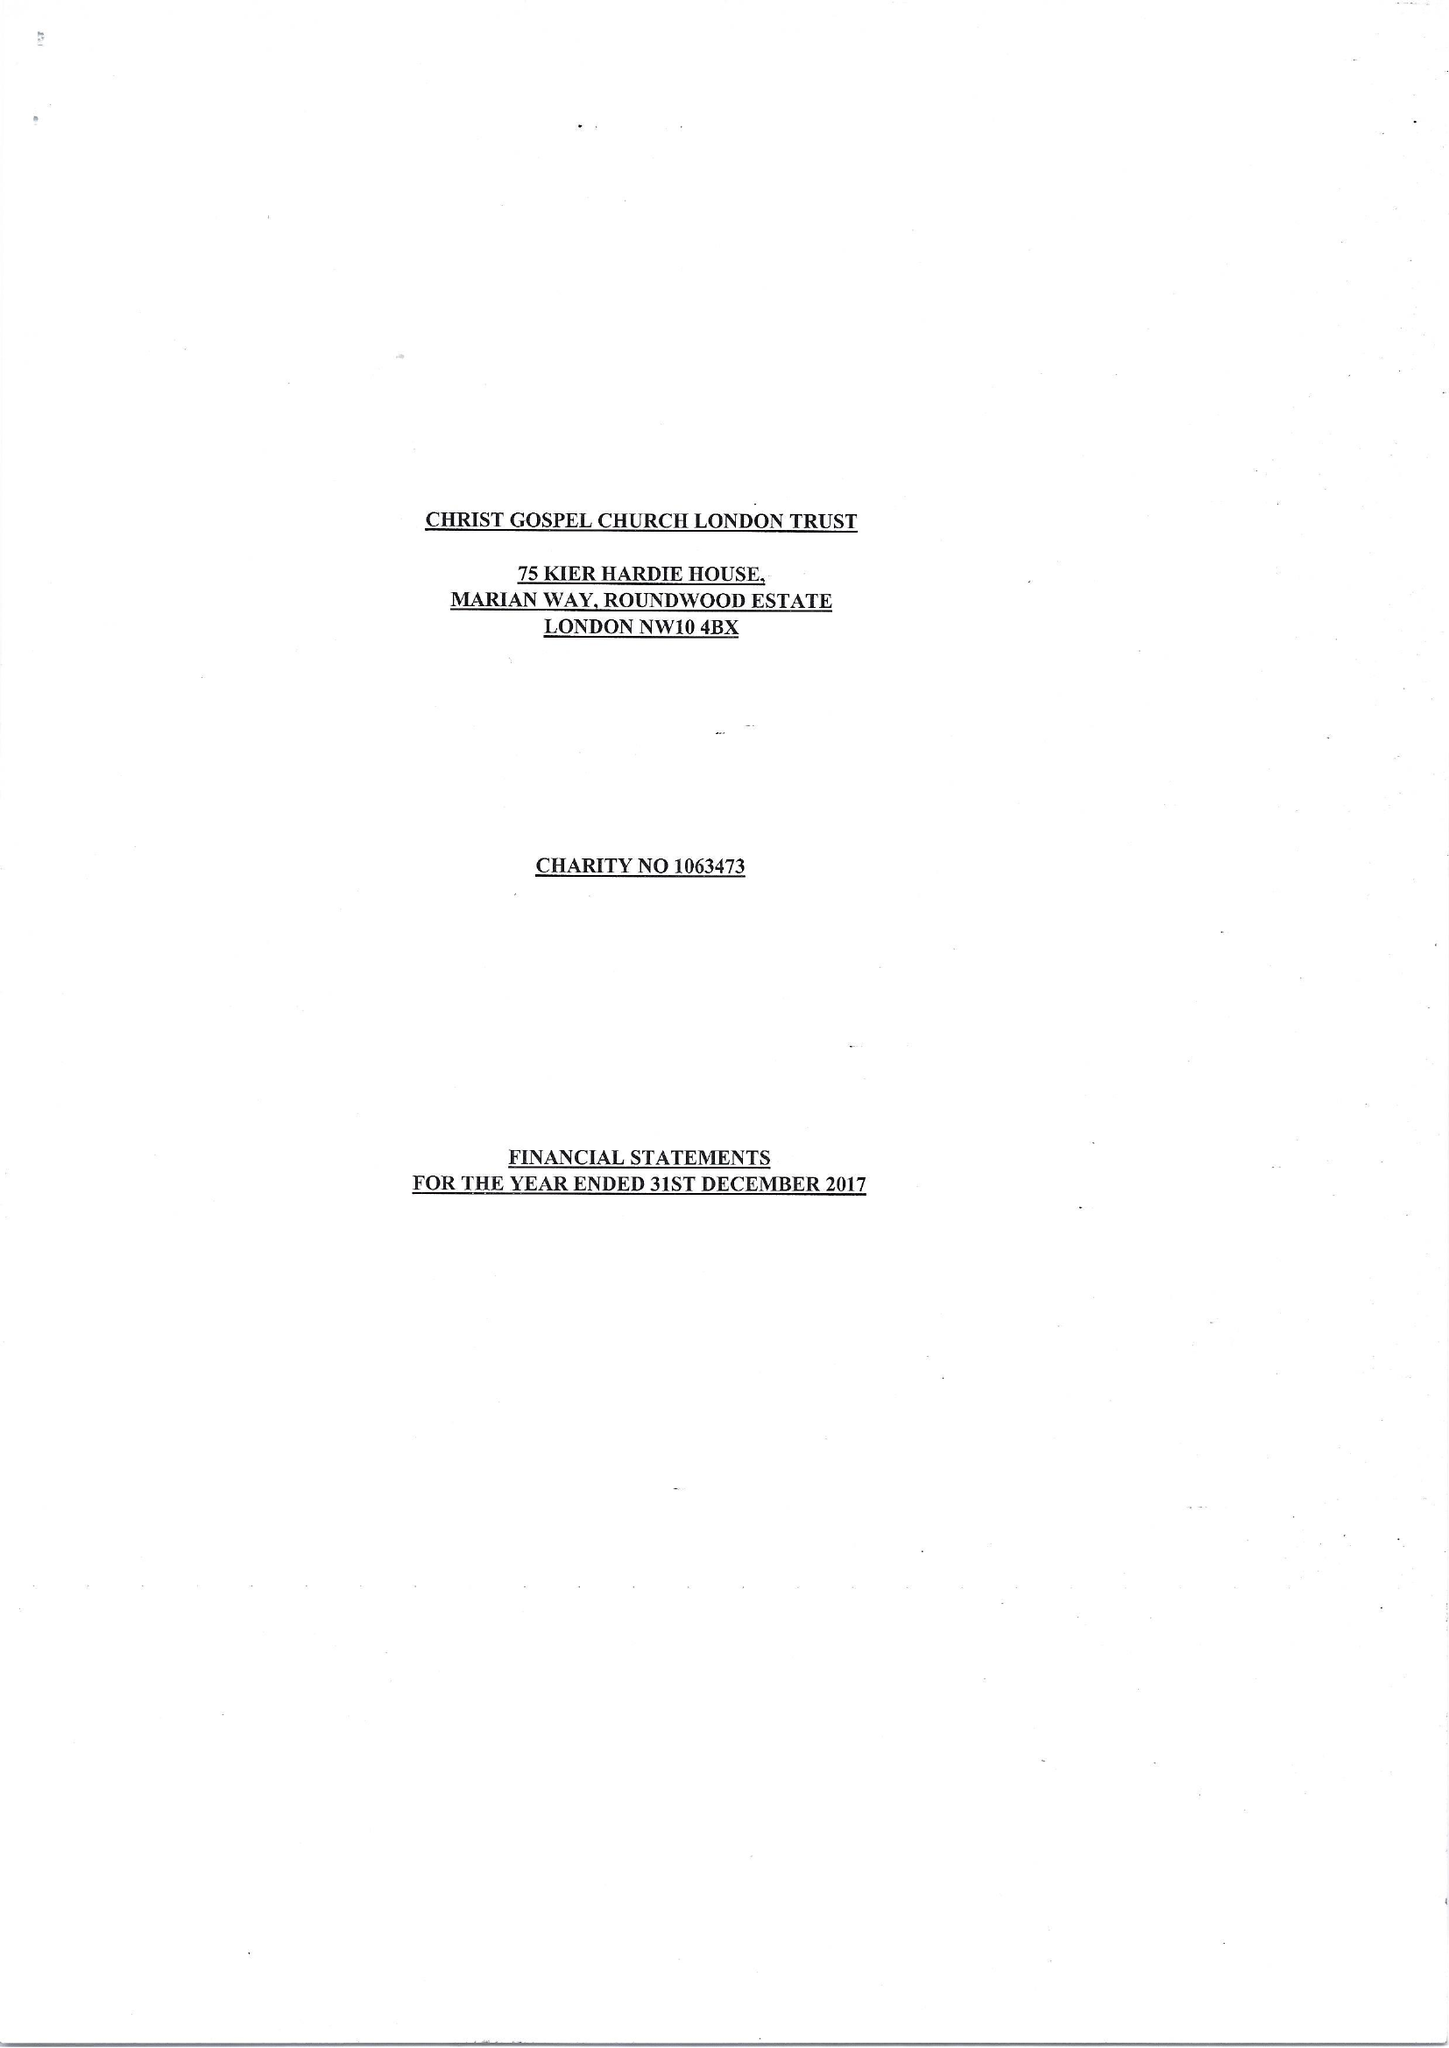What is the value for the address__street_line?
Answer the question using a single word or phrase. MARIAN WAY 